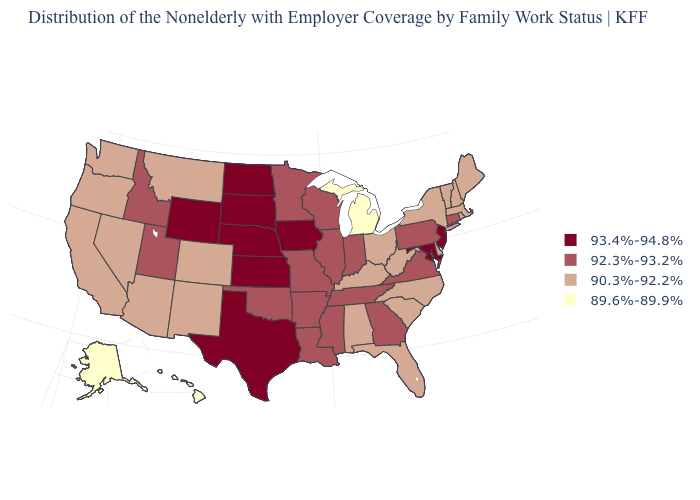What is the lowest value in the USA?
Quick response, please. 89.6%-89.9%. How many symbols are there in the legend?
Give a very brief answer. 4. What is the value of New Hampshire?
Quick response, please. 90.3%-92.2%. Name the states that have a value in the range 93.4%-94.8%?
Keep it brief. Iowa, Kansas, Maryland, Nebraska, New Jersey, North Dakota, South Dakota, Texas, Wyoming. Name the states that have a value in the range 89.6%-89.9%?
Quick response, please. Alaska, Hawaii, Michigan. Does South Dakota have the highest value in the MidWest?
Short answer required. Yes. Name the states that have a value in the range 92.3%-93.2%?
Quick response, please. Arkansas, Connecticut, Georgia, Idaho, Illinois, Indiana, Louisiana, Minnesota, Mississippi, Missouri, Oklahoma, Pennsylvania, Tennessee, Utah, Virginia, Wisconsin. Among the states that border North Dakota , does Minnesota have the lowest value?
Be succinct. No. How many symbols are there in the legend?
Give a very brief answer. 4. What is the highest value in states that border Louisiana?
Quick response, please. 93.4%-94.8%. Does New Hampshire have the highest value in the USA?
Be succinct. No. Which states have the highest value in the USA?
Answer briefly. Iowa, Kansas, Maryland, Nebraska, New Jersey, North Dakota, South Dakota, Texas, Wyoming. Does the first symbol in the legend represent the smallest category?
Answer briefly. No. What is the lowest value in the USA?
Answer briefly. 89.6%-89.9%. 